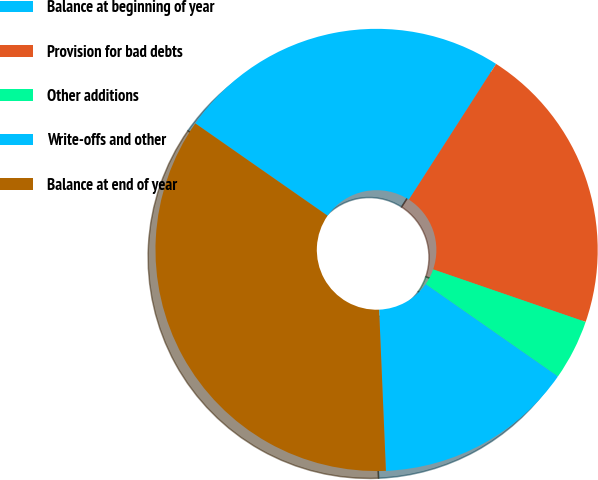Convert chart to OTSL. <chart><loc_0><loc_0><loc_500><loc_500><pie_chart><fcel>Balance at beginning of year<fcel>Provision for bad debts<fcel>Other additions<fcel>Write-offs and other<fcel>Balance at end of year<nl><fcel>24.39%<fcel>21.19%<fcel>4.42%<fcel>14.63%<fcel>35.37%<nl></chart> 